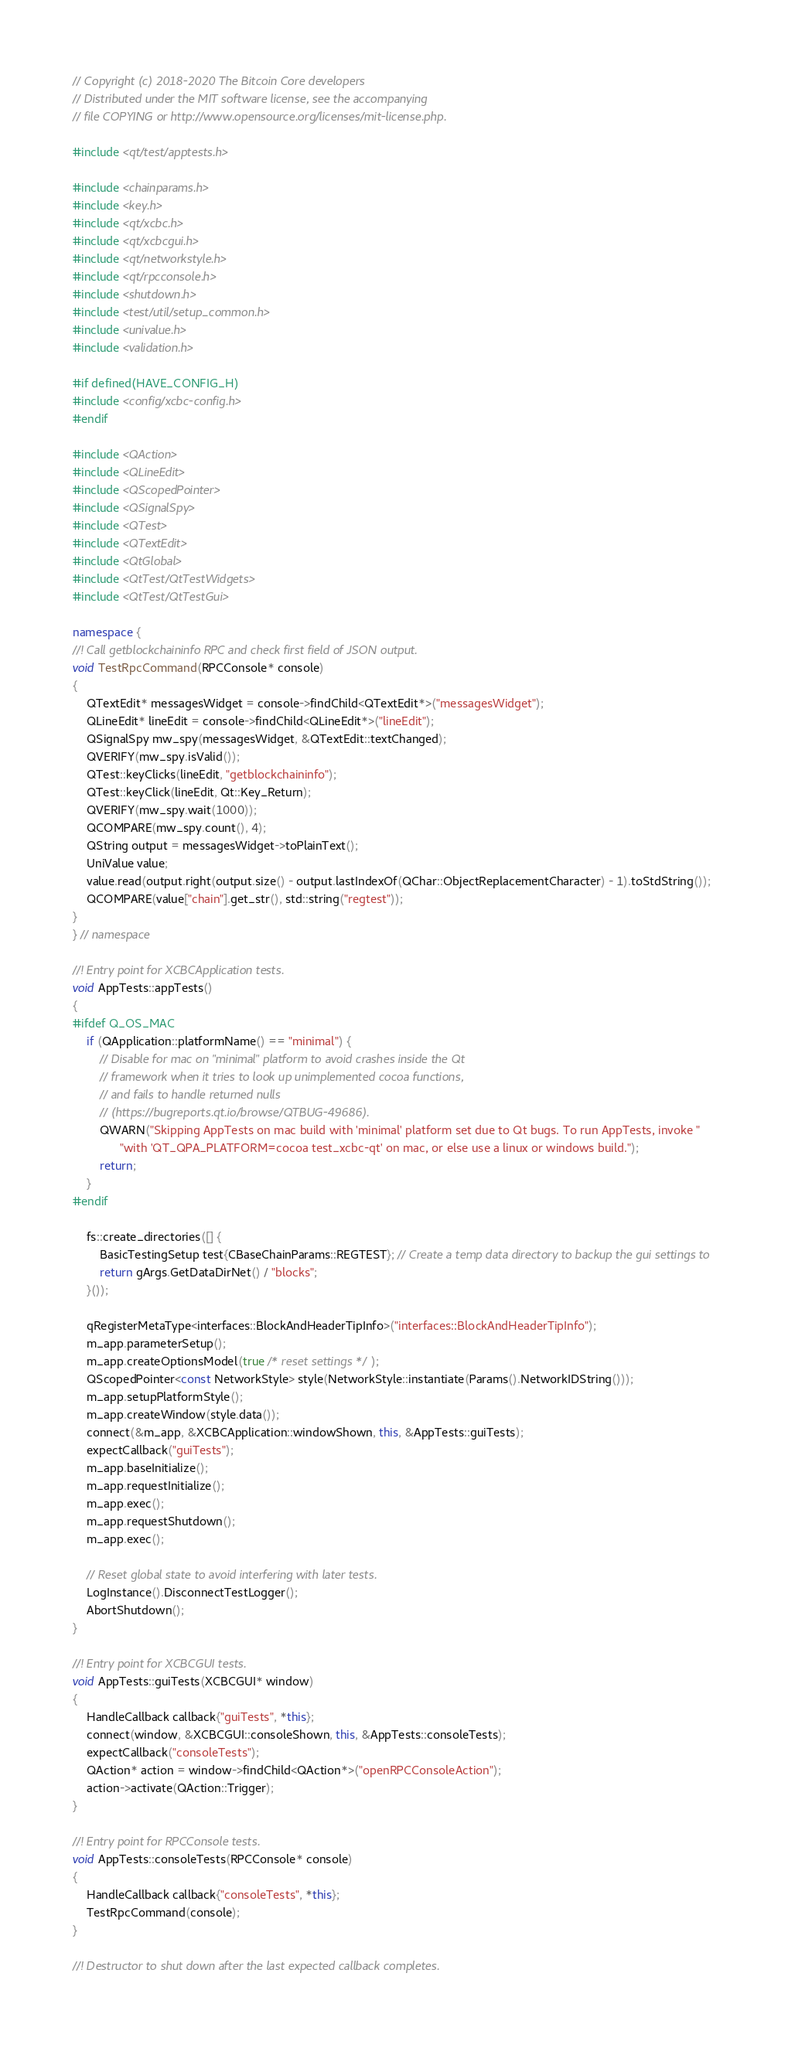Convert code to text. <code><loc_0><loc_0><loc_500><loc_500><_C++_>// Copyright (c) 2018-2020 The Bitcoin Core developers
// Distributed under the MIT software license, see the accompanying
// file COPYING or http://www.opensource.org/licenses/mit-license.php.

#include <qt/test/apptests.h>

#include <chainparams.h>
#include <key.h>
#include <qt/xcbc.h>
#include <qt/xcbcgui.h>
#include <qt/networkstyle.h>
#include <qt/rpcconsole.h>
#include <shutdown.h>
#include <test/util/setup_common.h>
#include <univalue.h>
#include <validation.h>

#if defined(HAVE_CONFIG_H)
#include <config/xcbc-config.h>
#endif

#include <QAction>
#include <QLineEdit>
#include <QScopedPointer>
#include <QSignalSpy>
#include <QTest>
#include <QTextEdit>
#include <QtGlobal>
#include <QtTest/QtTestWidgets>
#include <QtTest/QtTestGui>

namespace {
//! Call getblockchaininfo RPC and check first field of JSON output.
void TestRpcCommand(RPCConsole* console)
{
    QTextEdit* messagesWidget = console->findChild<QTextEdit*>("messagesWidget");
    QLineEdit* lineEdit = console->findChild<QLineEdit*>("lineEdit");
    QSignalSpy mw_spy(messagesWidget, &QTextEdit::textChanged);
    QVERIFY(mw_spy.isValid());
    QTest::keyClicks(lineEdit, "getblockchaininfo");
    QTest::keyClick(lineEdit, Qt::Key_Return);
    QVERIFY(mw_spy.wait(1000));
    QCOMPARE(mw_spy.count(), 4);
    QString output = messagesWidget->toPlainText();
    UniValue value;
    value.read(output.right(output.size() - output.lastIndexOf(QChar::ObjectReplacementCharacter) - 1).toStdString());
    QCOMPARE(value["chain"].get_str(), std::string("regtest"));
}
} // namespace

//! Entry point for XCBCApplication tests.
void AppTests::appTests()
{
#ifdef Q_OS_MAC
    if (QApplication::platformName() == "minimal") {
        // Disable for mac on "minimal" platform to avoid crashes inside the Qt
        // framework when it tries to look up unimplemented cocoa functions,
        // and fails to handle returned nulls
        // (https://bugreports.qt.io/browse/QTBUG-49686).
        QWARN("Skipping AppTests on mac build with 'minimal' platform set due to Qt bugs. To run AppTests, invoke "
              "with 'QT_QPA_PLATFORM=cocoa test_xcbc-qt' on mac, or else use a linux or windows build.");
        return;
    }
#endif

    fs::create_directories([] {
        BasicTestingSetup test{CBaseChainParams::REGTEST}; // Create a temp data directory to backup the gui settings to
        return gArgs.GetDataDirNet() / "blocks";
    }());

    qRegisterMetaType<interfaces::BlockAndHeaderTipInfo>("interfaces::BlockAndHeaderTipInfo");
    m_app.parameterSetup();
    m_app.createOptionsModel(true /* reset settings */);
    QScopedPointer<const NetworkStyle> style(NetworkStyle::instantiate(Params().NetworkIDString()));
    m_app.setupPlatformStyle();
    m_app.createWindow(style.data());
    connect(&m_app, &XCBCApplication::windowShown, this, &AppTests::guiTests);
    expectCallback("guiTests");
    m_app.baseInitialize();
    m_app.requestInitialize();
    m_app.exec();
    m_app.requestShutdown();
    m_app.exec();

    // Reset global state to avoid interfering with later tests.
    LogInstance().DisconnectTestLogger();
    AbortShutdown();
}

//! Entry point for XCBCGUI tests.
void AppTests::guiTests(XCBCGUI* window)
{
    HandleCallback callback{"guiTests", *this};
    connect(window, &XCBCGUI::consoleShown, this, &AppTests::consoleTests);
    expectCallback("consoleTests");
    QAction* action = window->findChild<QAction*>("openRPCConsoleAction");
    action->activate(QAction::Trigger);
}

//! Entry point for RPCConsole tests.
void AppTests::consoleTests(RPCConsole* console)
{
    HandleCallback callback{"consoleTests", *this};
    TestRpcCommand(console);
}

//! Destructor to shut down after the last expected callback completes.</code> 